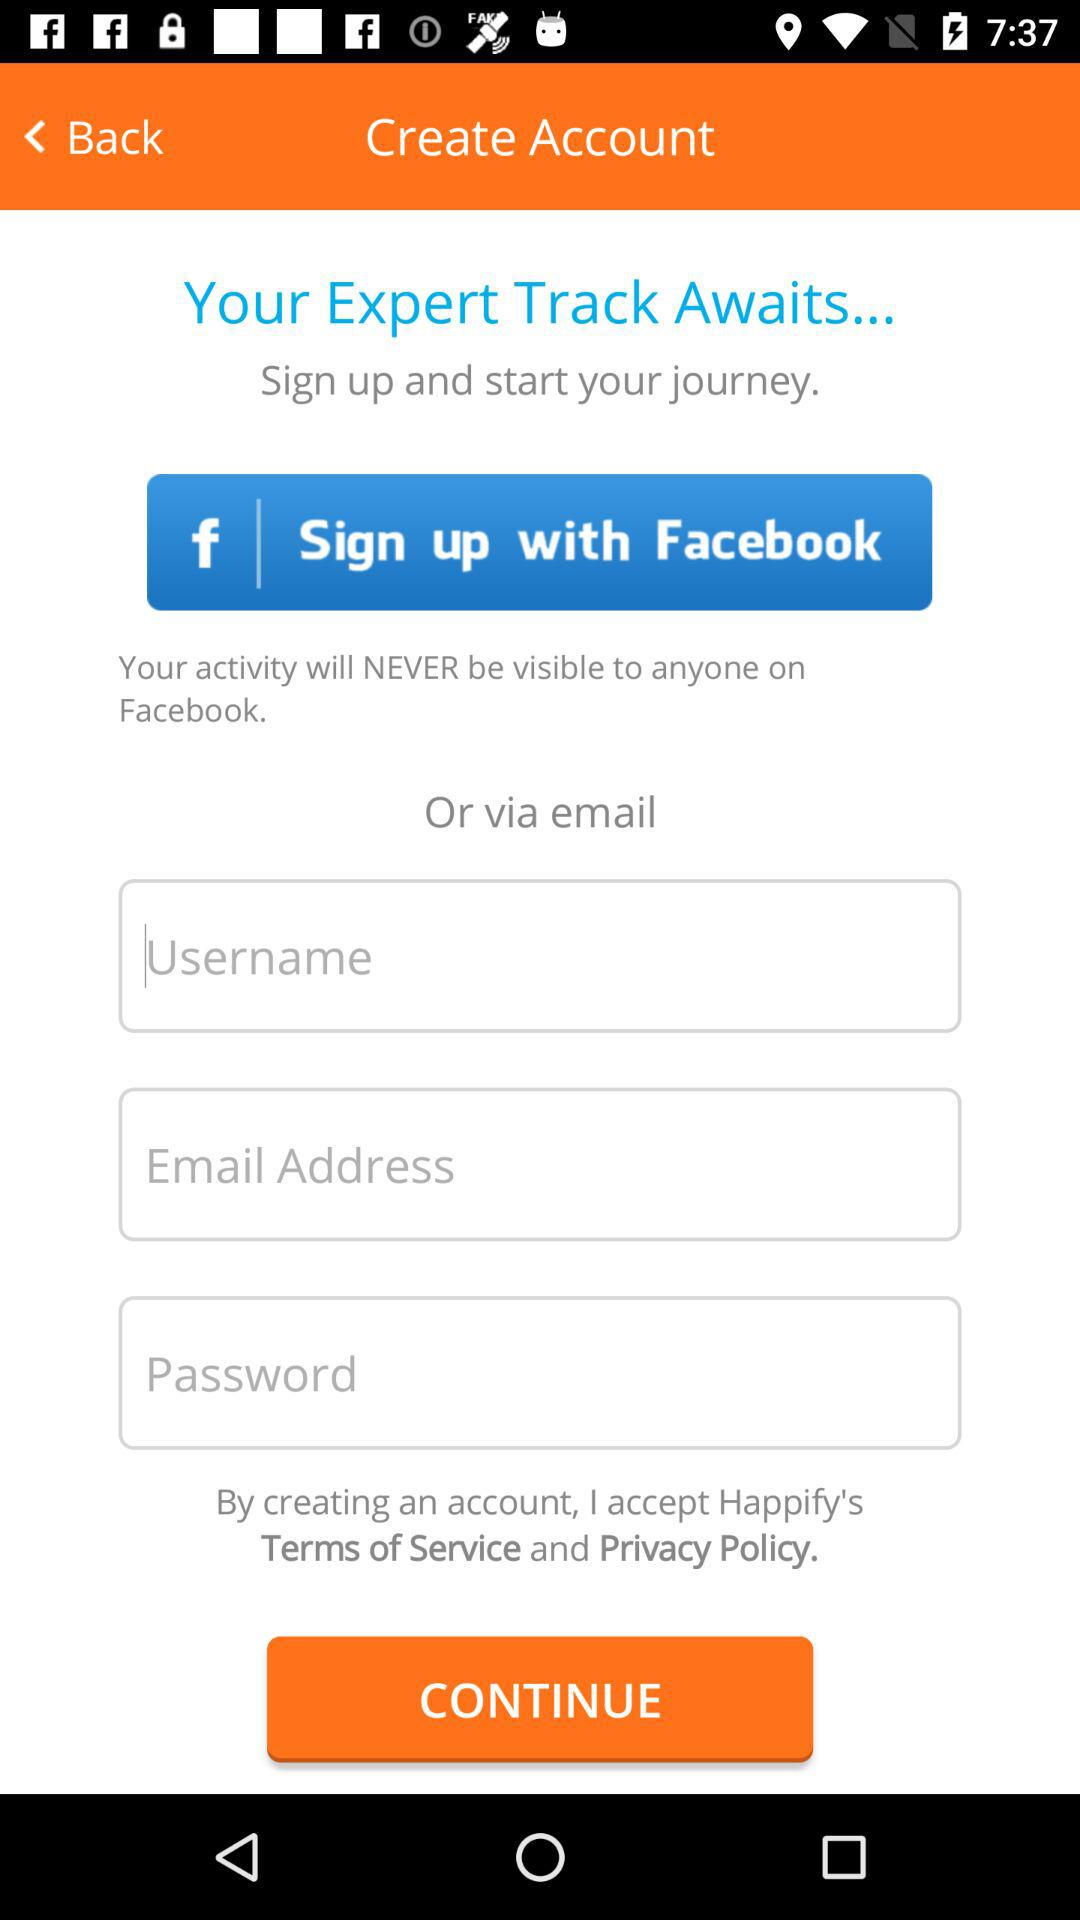What are the different options available for signup? The different options are "Facebook" and "email". 